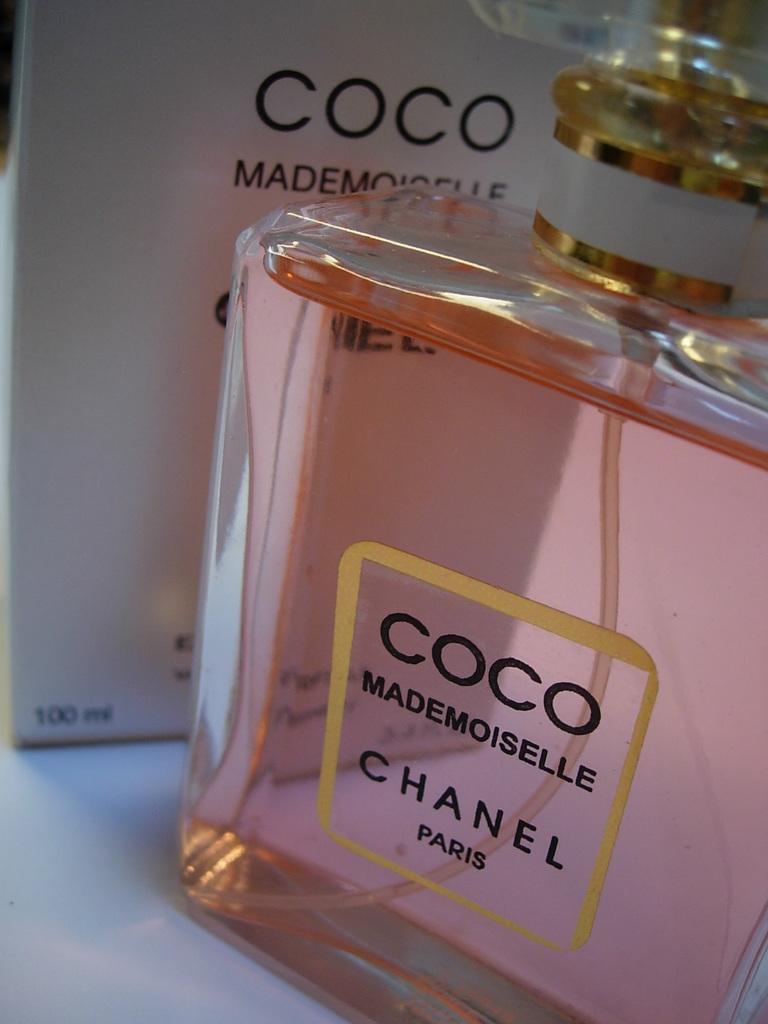What french city is written on the label?
Your response must be concise. Paris. How much perfume is in this container?
Your answer should be very brief. 100 ml. 